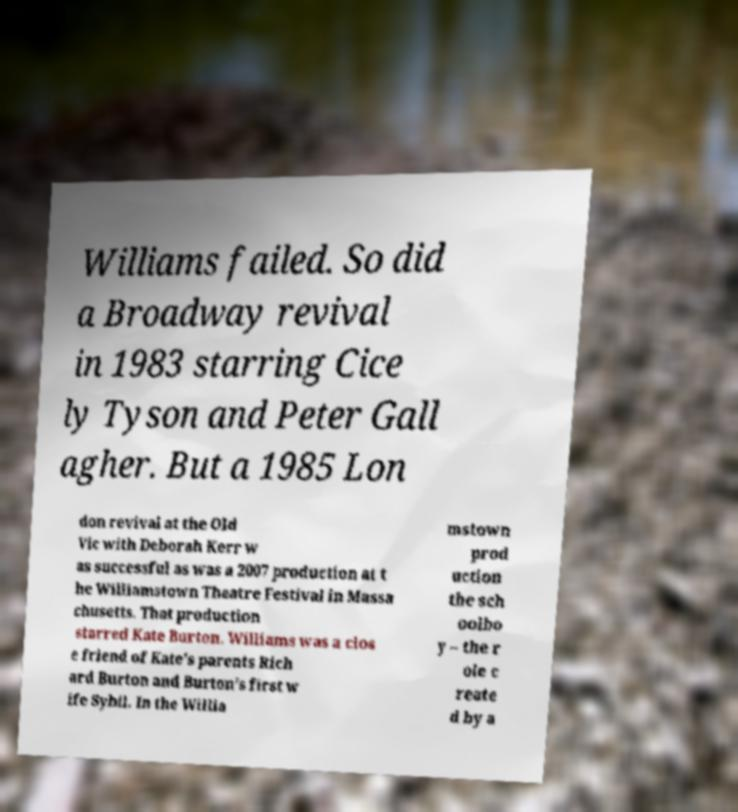Could you assist in decoding the text presented in this image and type it out clearly? Williams failed. So did a Broadway revival in 1983 starring Cice ly Tyson and Peter Gall agher. But a 1985 Lon don revival at the Old Vic with Deborah Kerr w as successful as was a 2007 production at t he Williamstown Theatre Festival in Massa chusetts. That production starred Kate Burton. Williams was a clos e friend of Kate's parents Rich ard Burton and Burton's first w ife Sybil. In the Willia mstown prod uction the sch oolbo y – the r ole c reate d by a 